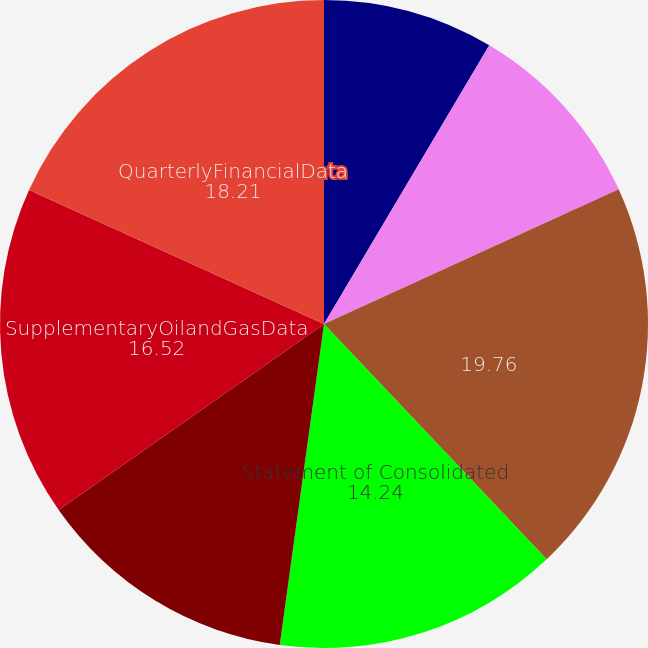Convert chart. <chart><loc_0><loc_0><loc_500><loc_500><pie_chart><fcel>Management's Report on<fcel>Reports of Independent<fcel>Unnamed: 2<fcel>Statement of Consolidated<fcel>Statement of Consolidated Cash<fcel>SupplementaryOilandGasData<fcel>QuarterlyFinancialData<nl><fcel>8.52%<fcel>9.66%<fcel>19.76%<fcel>14.24%<fcel>13.09%<fcel>16.52%<fcel>18.21%<nl></chart> 